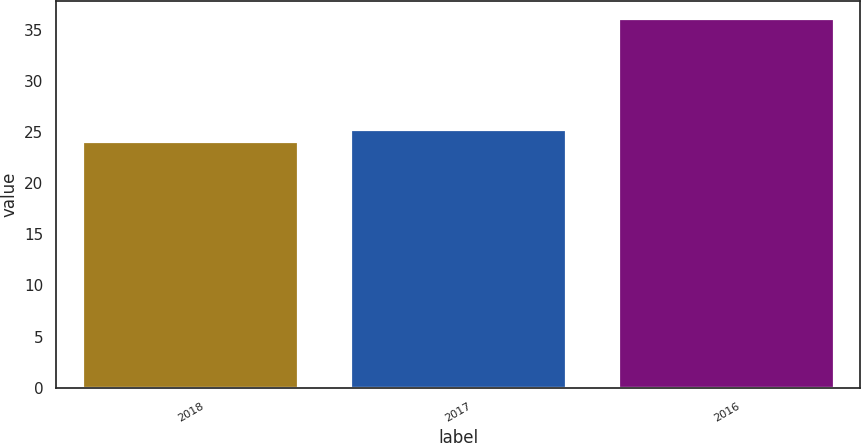Convert chart. <chart><loc_0><loc_0><loc_500><loc_500><bar_chart><fcel>2018<fcel>2017<fcel>2016<nl><fcel>24<fcel>25.2<fcel>36<nl></chart> 